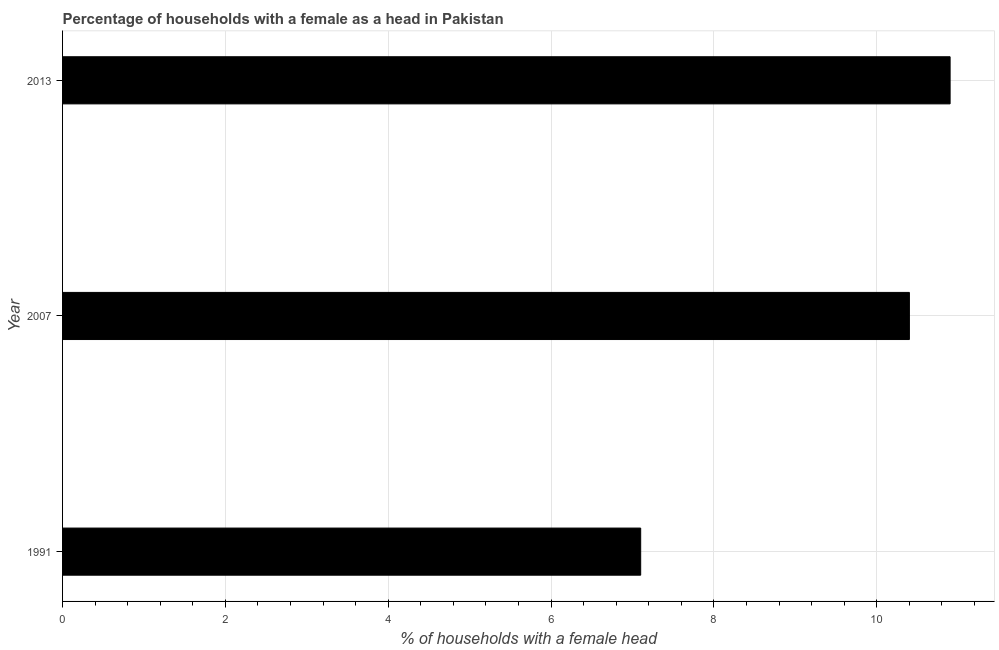Does the graph contain any zero values?
Provide a succinct answer. No. What is the title of the graph?
Offer a very short reply. Percentage of households with a female as a head in Pakistan. What is the label or title of the X-axis?
Keep it short and to the point. % of households with a female head. What is the label or title of the Y-axis?
Make the answer very short. Year. What is the number of female supervised households in 1991?
Provide a short and direct response. 7.1. Across all years, what is the maximum number of female supervised households?
Offer a very short reply. 10.9. Across all years, what is the minimum number of female supervised households?
Make the answer very short. 7.1. In which year was the number of female supervised households maximum?
Your answer should be very brief. 2013. In which year was the number of female supervised households minimum?
Make the answer very short. 1991. What is the sum of the number of female supervised households?
Make the answer very short. 28.4. What is the difference between the number of female supervised households in 1991 and 2007?
Your response must be concise. -3.3. What is the average number of female supervised households per year?
Keep it short and to the point. 9.47. In how many years, is the number of female supervised households greater than 2.8 %?
Your answer should be compact. 3. Do a majority of the years between 1991 and 2013 (inclusive) have number of female supervised households greater than 7.2 %?
Provide a short and direct response. Yes. What is the ratio of the number of female supervised households in 2007 to that in 2013?
Your answer should be very brief. 0.95. Is the difference between the number of female supervised households in 2007 and 2013 greater than the difference between any two years?
Provide a succinct answer. No. What is the difference between the highest and the lowest number of female supervised households?
Make the answer very short. 3.8. How many bars are there?
Make the answer very short. 3. Are all the bars in the graph horizontal?
Provide a succinct answer. Yes. What is the % of households with a female head in 1991?
Your answer should be compact. 7.1. What is the % of households with a female head in 2007?
Make the answer very short. 10.4. What is the difference between the % of households with a female head in 1991 and 2013?
Your response must be concise. -3.8. What is the difference between the % of households with a female head in 2007 and 2013?
Your answer should be compact. -0.5. What is the ratio of the % of households with a female head in 1991 to that in 2007?
Your response must be concise. 0.68. What is the ratio of the % of households with a female head in 1991 to that in 2013?
Provide a short and direct response. 0.65. What is the ratio of the % of households with a female head in 2007 to that in 2013?
Make the answer very short. 0.95. 